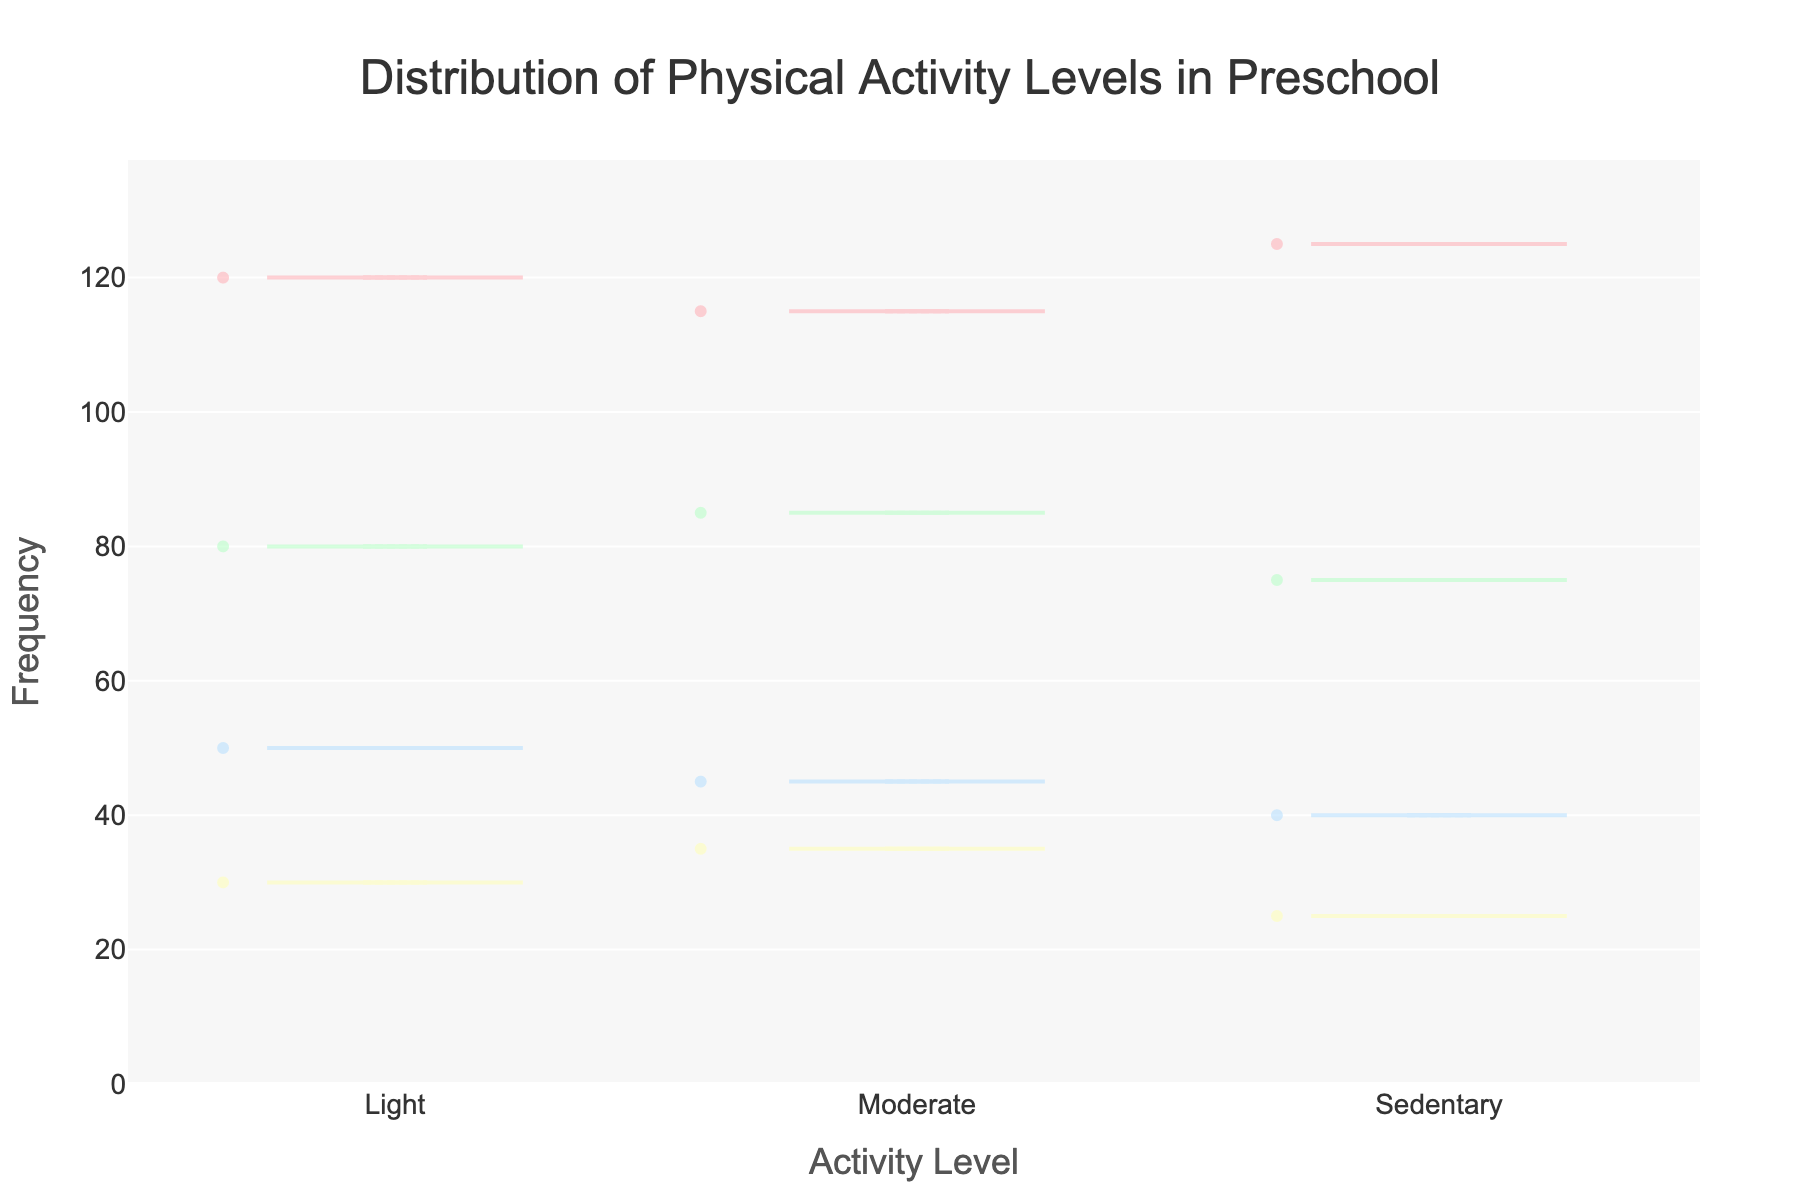What is the title of the plot? The title is situated at the top center of the plot, specified in a large font for clarity, and it reads 'Distribution of Physical Activity Levels in Preschool'.
Answer: Distribution of Physical Activity Levels in Preschool What are the four activity levels compared in this plot? The x-axis of the plot lists out the different activity levels. Looking at it, we see 'Sedentary', 'Light', 'Moderate', and 'Vigorous'.
Answer: Sedentary, Light, Moderate, Vigorous Which activity level has the highest mean frequency? Observing the different violin plots and noting the position of the mean line, 'Light' has the highest mean frequency among the other activity levels displayed.
Answer: Light How does the frequency distribution of 'Vigorous' activity compare to 'Moderate' activity? Comparing the width and spread of the two violin plots, 'Moderate' activity shows a wider and denser distribution while 'Vigorous' is narrower indicating fewer data points and lower frequencies overall.
Answer: 'Moderate' has denser distribution than 'Vigorous' What is the range of frequencies observed for 'Sedentary' activity level? By looking at the extent of the 'Sedentary' violin plot along the y-axis, the frequencies range from approximately 40 to 50.
Answer: Approximately 40 to 50 Which activity level appears to have the most varied frequencies? The spread and width of the violin plots indicate variability; 'Light' activity shows the widest spread, indicating it has the most varied frequencies.
Answer: Light Which activity level has the smallest maximum frequency observed? By looking at the top edges of each violin plot, 'Vigorous' activity shows the smallest maximum frequency observed, peaking at around 35.
Answer: Vigorous What is the typical frequency (mean value) of moderate activity? The mean line for 'Moderate' in the violin plot represents the typical frequency, which appears to be around 80.
Answer: 80 Are there more data points for 'Light' or 'Sedentary' activity? Observing the density and spread of the points within each of the respective violin plots, 'Light' activity clearly has more data points when compared to 'Sedentary'.
Answer: Light Which activity level shows the least variation in its frequency? The narrowness and concentrated distribution of the violin plot for 'Vigorous' suggest it shows the least variation in its frequency.
Answer: Vigorous 